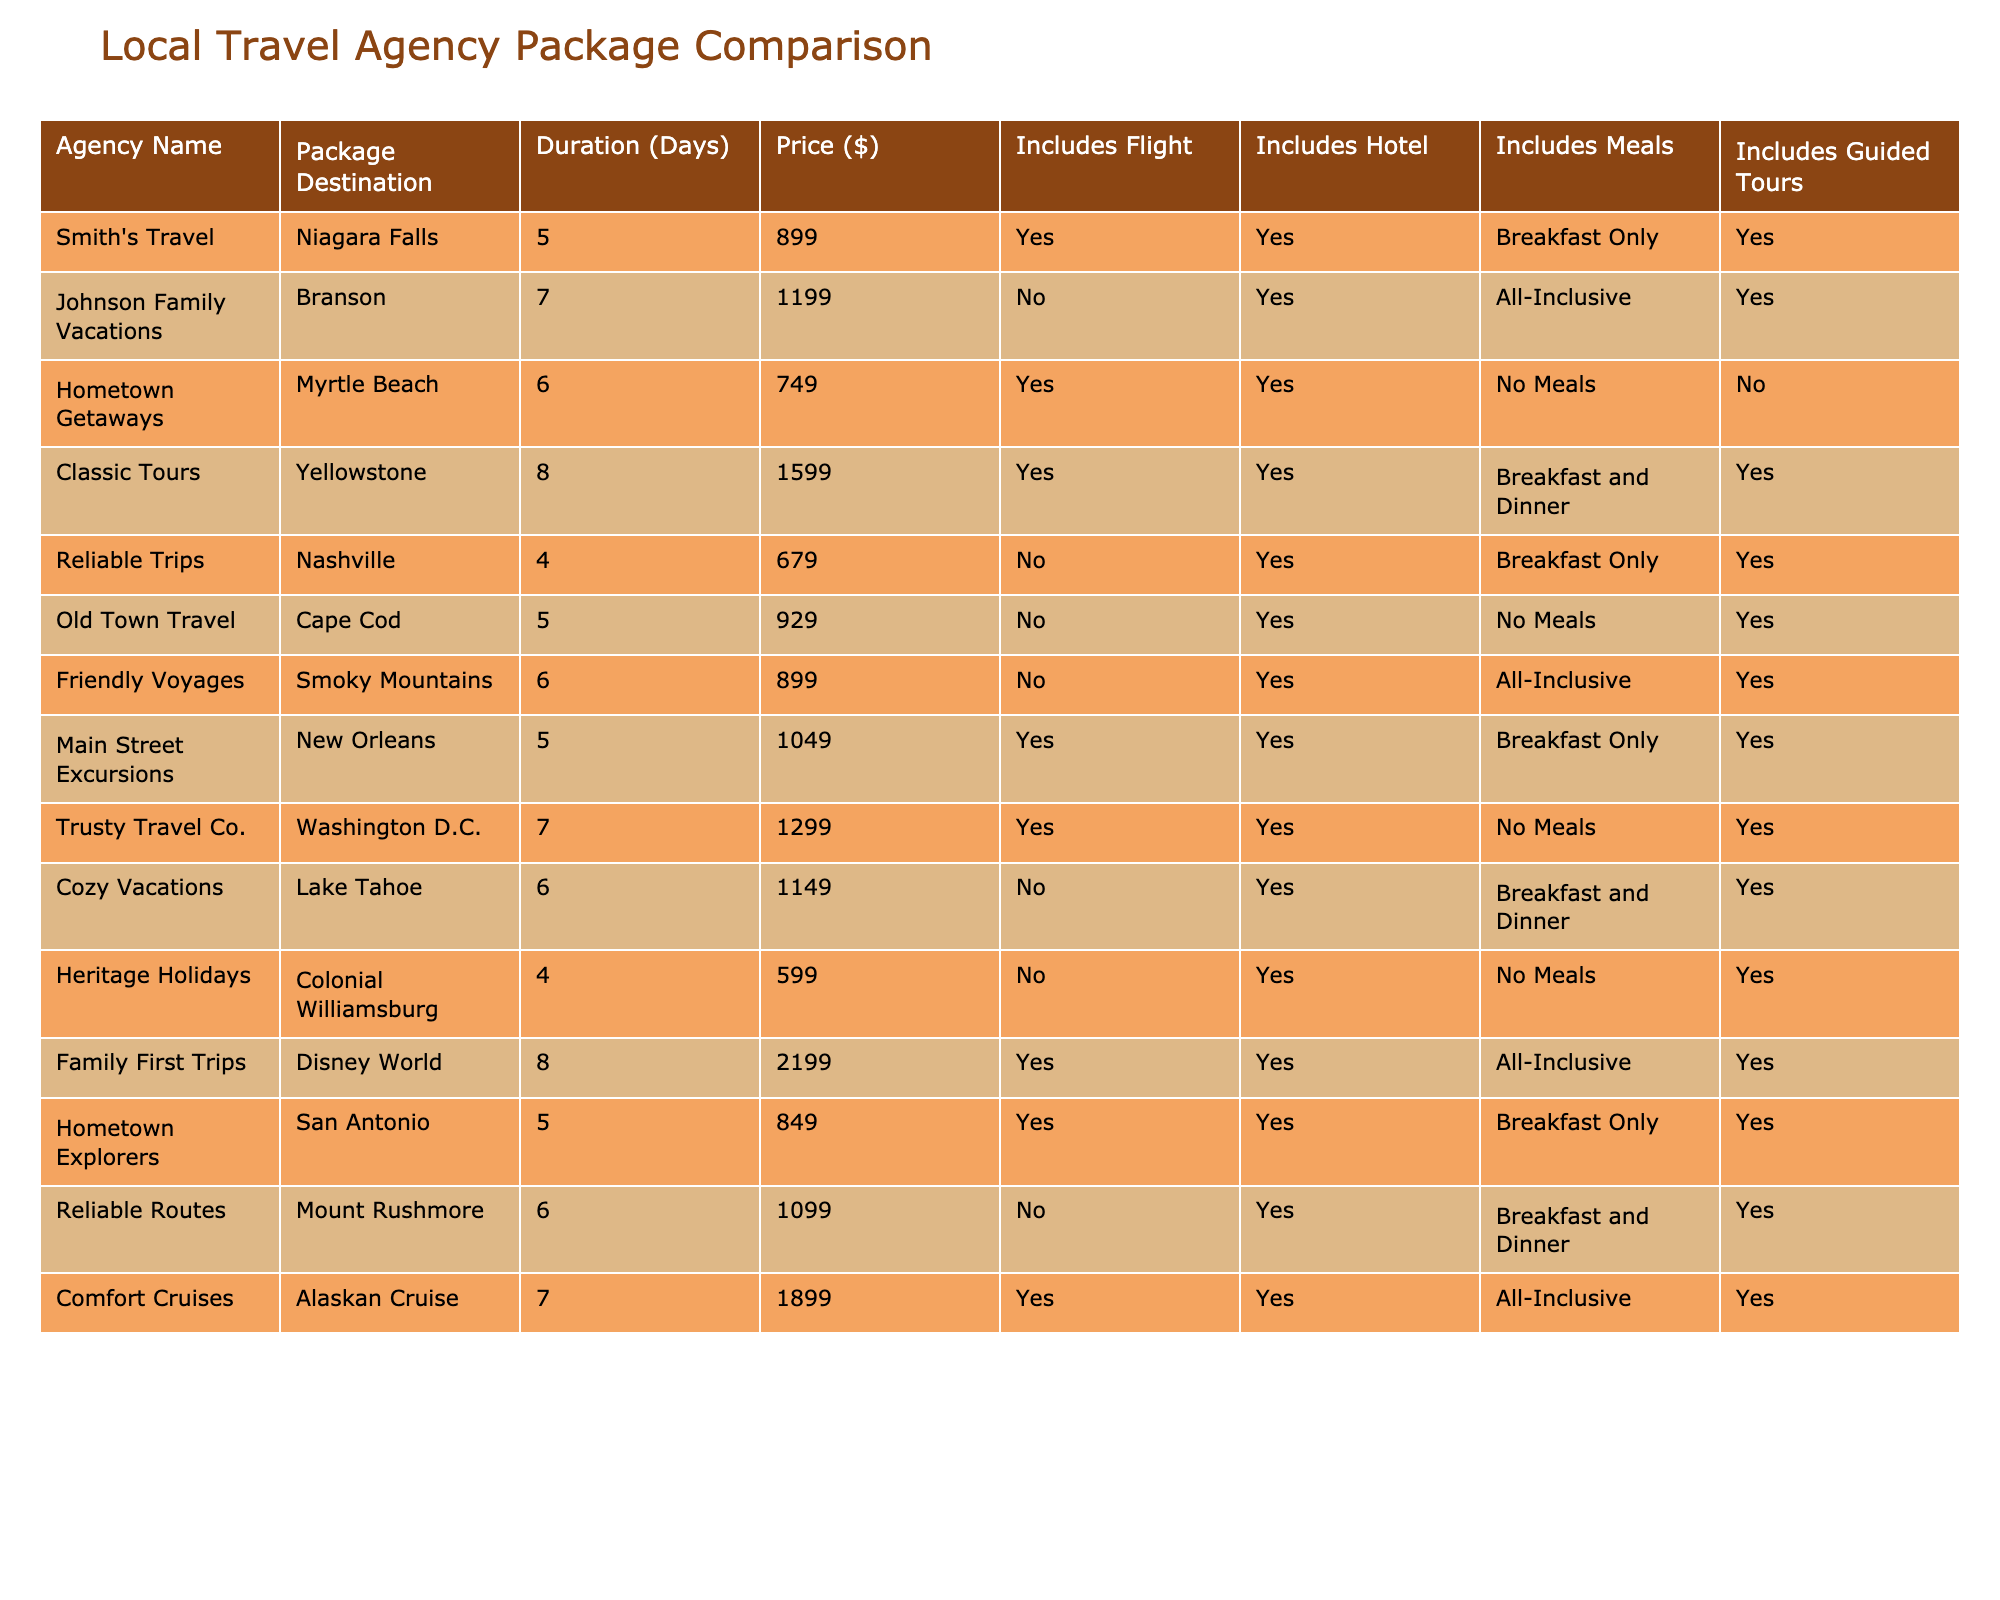What is the price of the travel package to Niagara Falls? The price of the package offered by Smith's Travel for Niagara Falls is mentioned in the table under the 'Price ($)' column. It shows $899.
Answer: 899 Which agencies include meals in their travel packages? To find which agencies include meals, we can look at the 'Includes Meals' column and check for 'Yes'. The agencies are Smith's Travel, Johnson Family Vacations, Classic Tours, Reliable Trips, Main Street Excursions, Trusty Travel Co., Cozy Vacations, Family First Trips, Hometown Explorers, and Reliable Routes.
Answer: 10 What is the average price of all travel packages? To calculate the average price, we sum the prices of all packages: 899 + 1199 + 749 + 1599 + 679 + 929 + 899 + 1049 + 1299 + 1149 + 599 + 2199 + 849 + 1099 + 1899 = 15699. Then divide by the number of packages (14): 15699 / 14 = 1121.36.
Answer: 1121.36 How many days is the Disney World package offered by Family First Trips? The duration for the package offered by Family First Trips is specified in the 'Duration (Days)' column next to the Disney World package. It indicates 8 days.
Answer: 8 Which agency has the highest priced travel package and what is the destination? By examining the 'Price ($)' column, we find that the highest price is $2199, which corresponds to the package offered by Family First Trips for Disney World.
Answer: Family First Trips, Disney World Do any travel packages include both guided tours and meals? To verify, we check the 'Includes Guided Tours' and 'Includes Meals' columns. The agencies that meet both criteria are Smith's Travel, Johnson Family Vacations, Classic Tours, Reliable Trips, Main Street Excursions, and Cozy Vacations.
Answer: 6 Which agency offers the shortest travel package duration? To find the shortest duration, look for the minimum value in the 'Duration (Days)' column. The shortest duration shown is 4 days by Reliable Trips and Heritage Holidays.
Answer: 4 Days Is there a package that includes flights and has a duration of 6 days? In the table, we check the 'Includes Flight' and 'Duration (Days)' columns. The only package that fits is Hometown Getaways (Myrtle Beach), which is 6 days and includes flights.
Answer: Yes What is the total cost of all packages that include hotel accommodation? We sum the prices of all packages where 'Includes Hotel' is 'Yes'. The prices are: 899 + 1199 + 749 + 1599 + 679 + 929 + 899 + 1049 + 1299 + 1149 + 2199 + 849 + 1099 = 14859.
Answer: 14859 How many packages are offered by agencies that do not include flights? Count the entries in the 'Includes Flight' column that say 'No'. There are 7 agencies that offer packages without flights: Johnson Family Vacations, Reliable Trips, Old Town Travel, Friendly Voyages, Cozy Vacations, Heritage Holidays, and Trusty Travel Co.
Answer: 7 